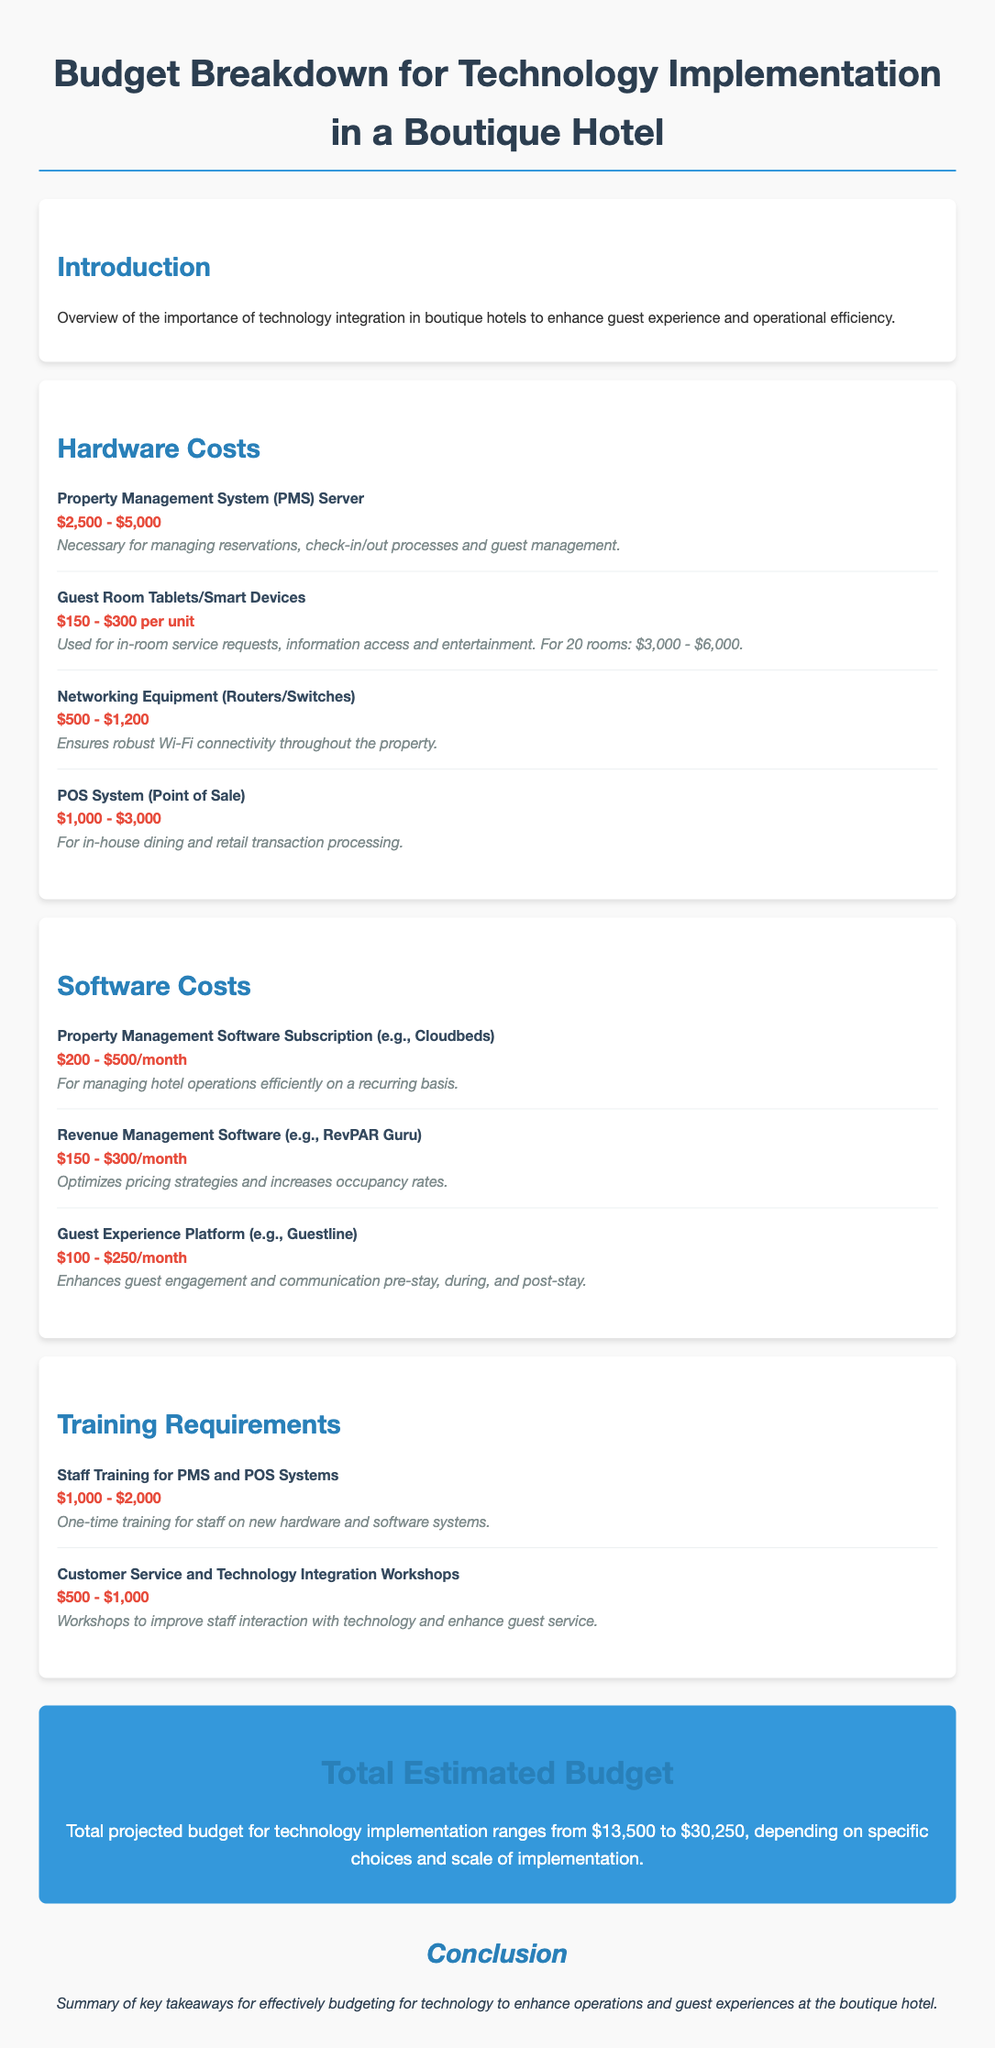What is the estimated range for the hardware costs? The document states that hardware costs range from $3,500 to $15,200.
Answer: $3,500 - $15,200 What is the cost estimate for Guest Room Tablets? The details for Guest Room Tablets specify a cost of $150 - $300 per unit and for 20 rooms: $3,000 - $6,000.
Answer: $3,000 - $6,000 What software is mentioned for Revenue Management? The document specifies Revenue Management Software as "RevPAR Guru."
Answer: RevPAR Guru What is the cost for staff training on PMS and POS systems? The cost for staff training on these systems is stated as a one-time expense of $1,000 - $2,000.
Answer: $1,000 - $2,000 What is the total projected budget for technology implementation? The total projected budget combines all costs and is stated to range from $13,500 to $30,250.
Answer: $13,500 - $30,250 How much is the monthly subscription for Property Management Software? The document indicates that the subscription costs between $200 - $500 per month.
Answer: $200 - $500/month What type of equipment is necessary for robust Wi-Fi connectivity? The document mentions "Networking Equipment (Routers/Switches)" for ensuring connectivity.
Answer: Networking Equipment (Routers/Switches) What is the focus of customer service workshops? The workshops aim to improve "staff interaction with technology and enhance guest service."
Answer: Staff interaction with technology and enhance guest service 